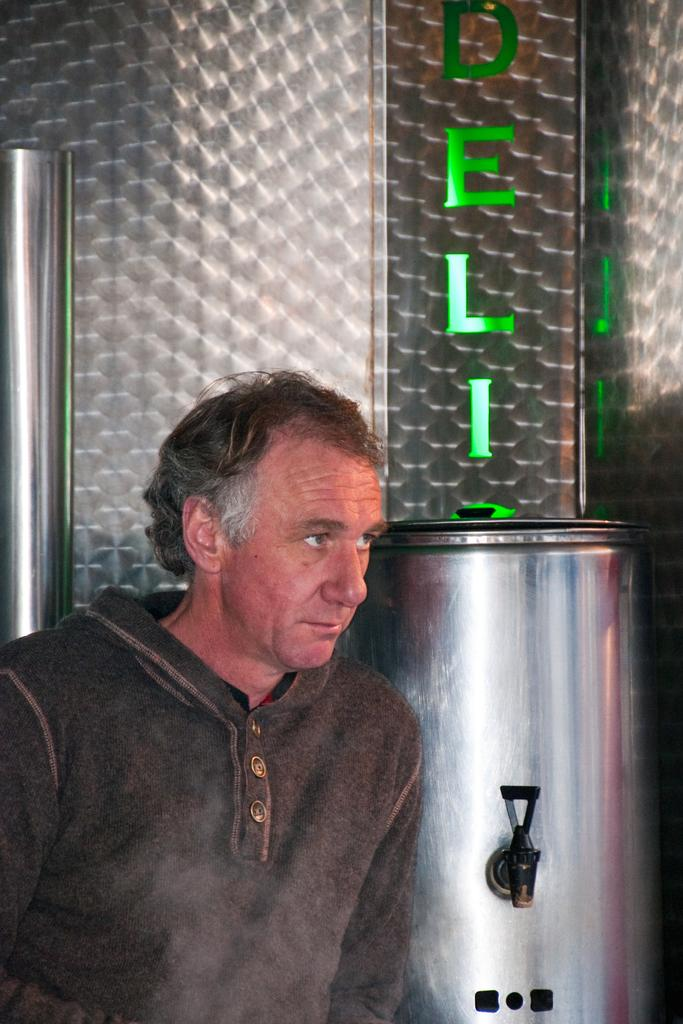<image>
Present a compact description of the photo's key features. A man standing in front of a silver drink dispenser with part of a word showing the first three letters ELI. 